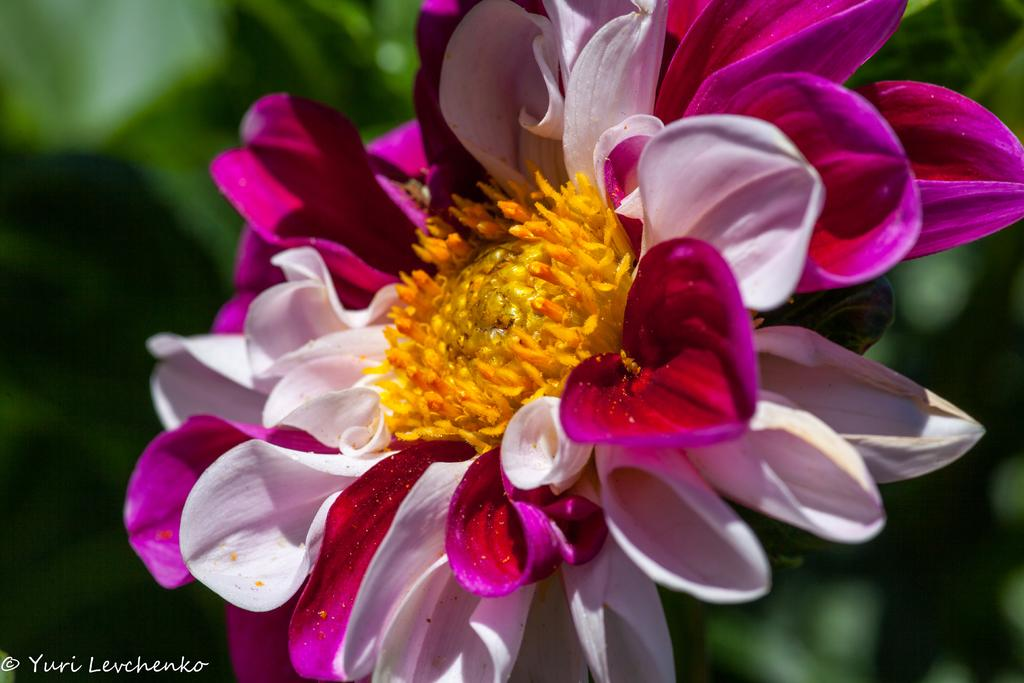What is the main subject of the image? There is a flower in the image. What colors can be seen on the flower? The flower has pink and white colors. What color is the background of the image? The background of the image is green. How is the background of the image depicted? The background is blurred. What type of dress is the flower wearing in the image? There is no dress present in the image, as the subject is a flower. 